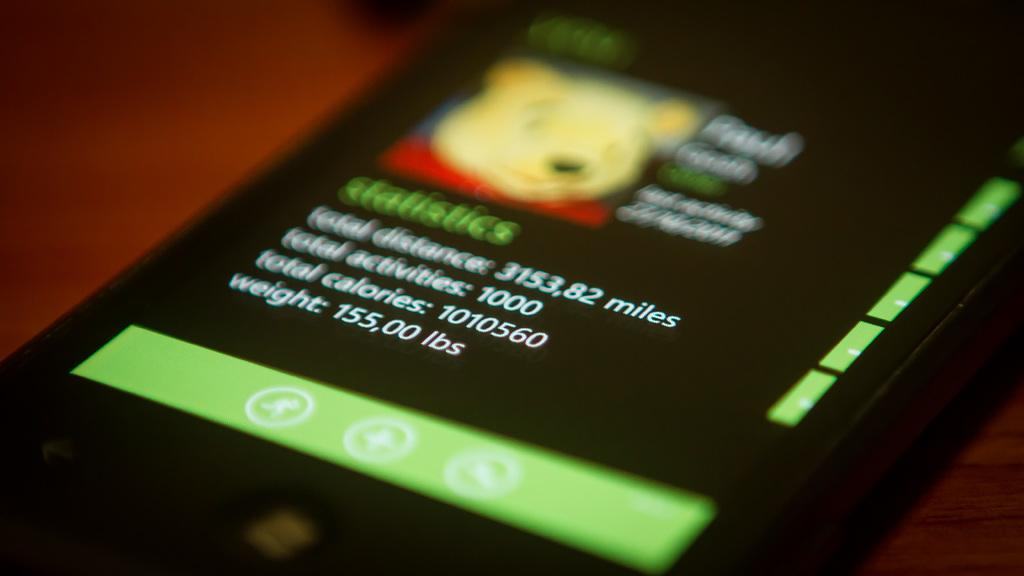Provide a one-sentence caption for the provided image. A phone screen with a picture of winnie the pooh on it. 